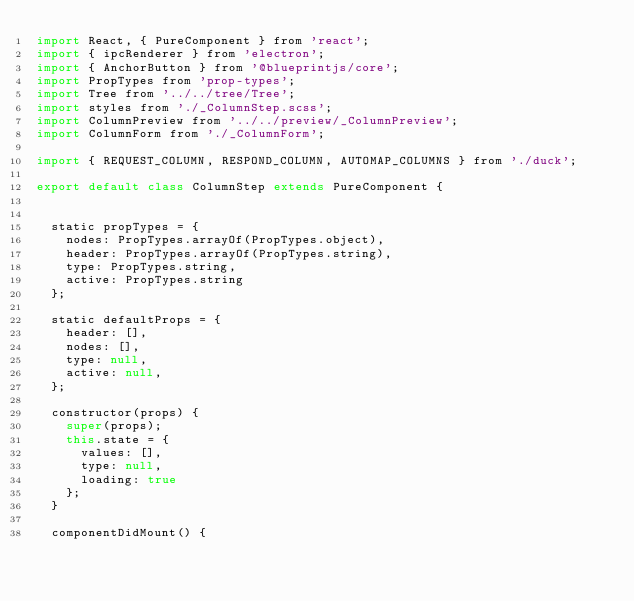<code> <loc_0><loc_0><loc_500><loc_500><_JavaScript_>import React, { PureComponent } from 'react';
import { ipcRenderer } from 'electron';
import { AnchorButton } from '@blueprintjs/core';
import PropTypes from 'prop-types';
import Tree from '../../tree/Tree';
import styles from './_ColumnStep.scss';
import ColumnPreview from '../../preview/_ColumnPreview';
import ColumnForm from './_ColumnForm';

import { REQUEST_COLUMN, RESPOND_COLUMN, AUTOMAP_COLUMNS } from './duck';

export default class ColumnStep extends PureComponent {


  static propTypes = {
    nodes: PropTypes.arrayOf(PropTypes.object),
    header: PropTypes.arrayOf(PropTypes.string),
    type: PropTypes.string,
    active: PropTypes.string
  };

  static defaultProps = {
    header: [],
    nodes: [],
    type: null,
    active: null,
  };

  constructor(props) {
    super(props);
    this.state = {
      values: [],
      type: null,
      loading: true
    };
  }

  componentDidMount() {</code> 